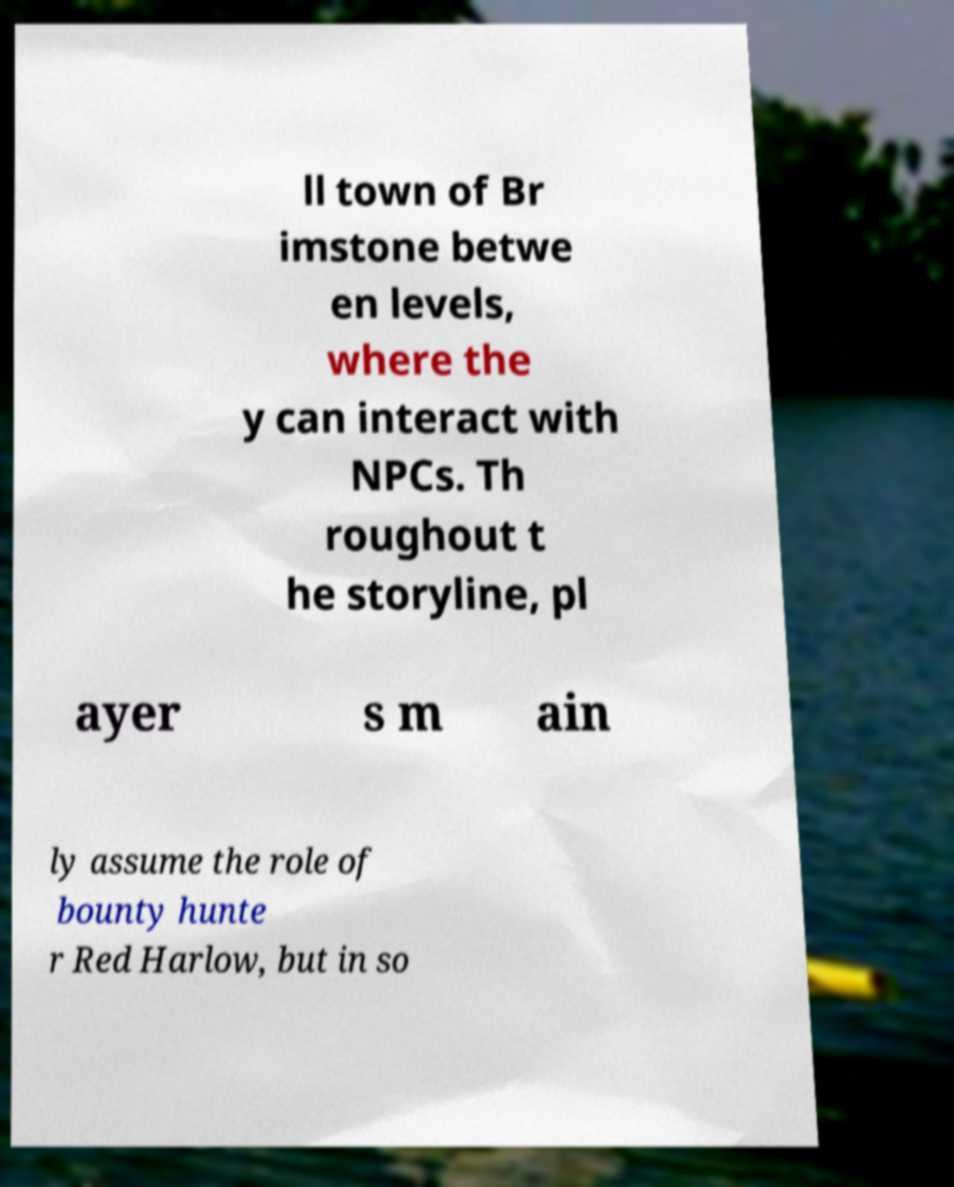Could you assist in decoding the text presented in this image and type it out clearly? ll town of Br imstone betwe en levels, where the y can interact with NPCs. Th roughout t he storyline, pl ayer s m ain ly assume the role of bounty hunte r Red Harlow, but in so 